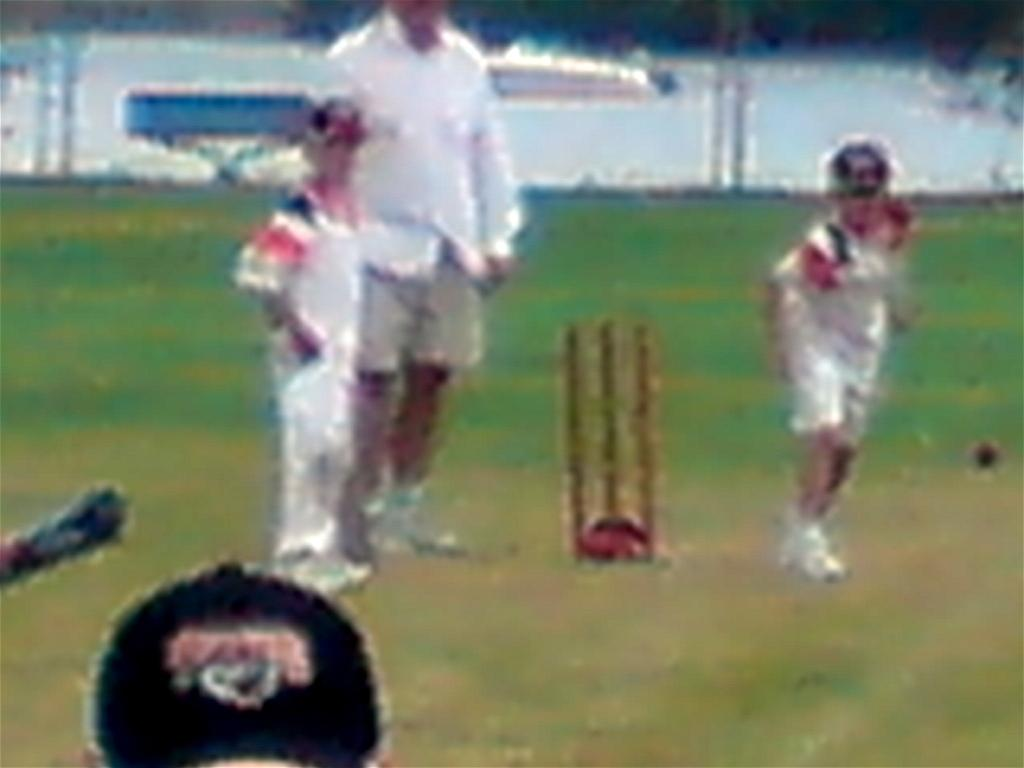Who or what can be seen in the image? There are people in the image. What is located on the right side of the image? There is a wicket on the right side of the image. What type of surface is visible on the ground in the image? There are grasses on the ground in the image. Can you describe the background of the image? The background of the image is blurred. Reasoning: Let'g: Let's think step by step in order to produce the conversation. We start by identifying the main subjects in the image, which are the people. Then, we describe the specific objects and features in the image, such as the wicket and the grasses on the ground. Finally, we mention the background of the image, noting that it is blurred. Each question is designed to elicit a specific detail about the image that is known from the provided facts. Absurd Question/Answer: What type of whistle can be heard in the image? There is no whistle present in the image, so it cannot be heard. How does the wind affect the people in the image? There is no mention of wind in the image, so its effect on the people cannot be determined. What type of chain can be seen connecting the people in the image? There is no chain present in the image, so it cannot be seen connecting the people. 